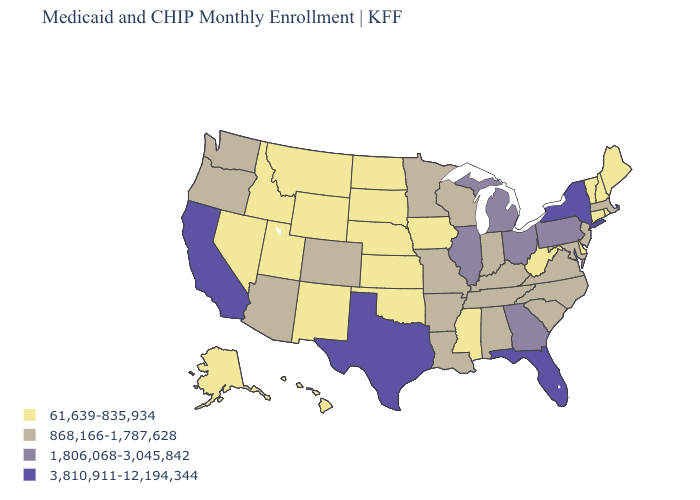Name the states that have a value in the range 3,810,911-12,194,344?
Write a very short answer. California, Florida, New York, Texas. Does the map have missing data?
Keep it brief. No. Does New York have the highest value in the USA?
Be succinct. Yes. Does the first symbol in the legend represent the smallest category?
Concise answer only. Yes. Name the states that have a value in the range 3,810,911-12,194,344?
Give a very brief answer. California, Florida, New York, Texas. What is the highest value in the USA?
Give a very brief answer. 3,810,911-12,194,344. Name the states that have a value in the range 61,639-835,934?
Concise answer only. Alaska, Connecticut, Delaware, Hawaii, Idaho, Iowa, Kansas, Maine, Mississippi, Montana, Nebraska, Nevada, New Hampshire, New Mexico, North Dakota, Oklahoma, Rhode Island, South Dakota, Utah, Vermont, West Virginia, Wyoming. Name the states that have a value in the range 61,639-835,934?
Be succinct. Alaska, Connecticut, Delaware, Hawaii, Idaho, Iowa, Kansas, Maine, Mississippi, Montana, Nebraska, Nevada, New Hampshire, New Mexico, North Dakota, Oklahoma, Rhode Island, South Dakota, Utah, Vermont, West Virginia, Wyoming. Name the states that have a value in the range 61,639-835,934?
Write a very short answer. Alaska, Connecticut, Delaware, Hawaii, Idaho, Iowa, Kansas, Maine, Mississippi, Montana, Nebraska, Nevada, New Hampshire, New Mexico, North Dakota, Oklahoma, Rhode Island, South Dakota, Utah, Vermont, West Virginia, Wyoming. Among the states that border Pennsylvania , which have the highest value?
Keep it brief. New York. What is the value of Kentucky?
Concise answer only. 868,166-1,787,628. Name the states that have a value in the range 61,639-835,934?
Keep it brief. Alaska, Connecticut, Delaware, Hawaii, Idaho, Iowa, Kansas, Maine, Mississippi, Montana, Nebraska, Nevada, New Hampshire, New Mexico, North Dakota, Oklahoma, Rhode Island, South Dakota, Utah, Vermont, West Virginia, Wyoming. What is the lowest value in the USA?
Give a very brief answer. 61,639-835,934. Does Kentucky have the lowest value in the USA?
Give a very brief answer. No. Among the states that border West Virginia , does Virginia have the highest value?
Quick response, please. No. 